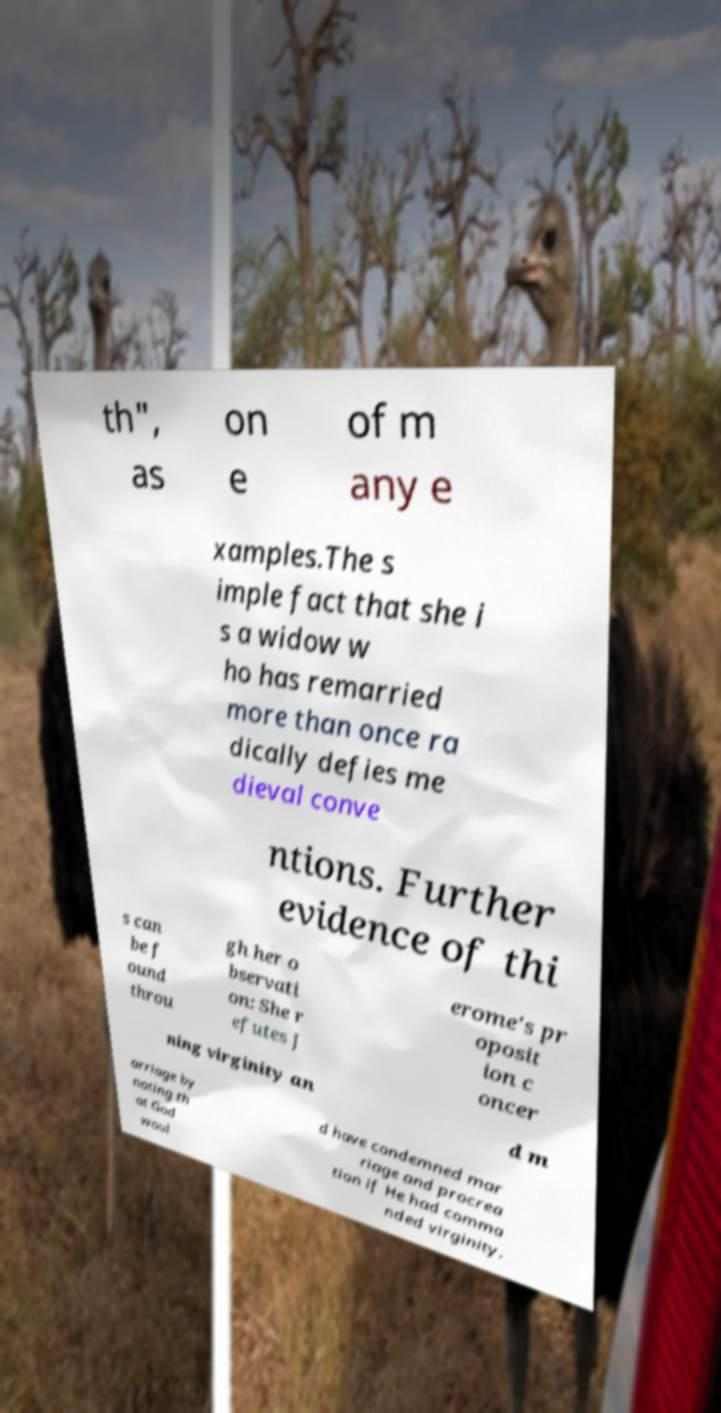I need the written content from this picture converted into text. Can you do that? th", as on e of m any e xamples.The s imple fact that she i s a widow w ho has remarried more than once ra dically defies me dieval conve ntions. Further evidence of thi s can be f ound throu gh her o bservati on: She r efutes J erome's pr oposit ion c oncer ning virginity an d m arriage by noting th at God woul d have condemned mar riage and procrea tion if He had comma nded virginity. 